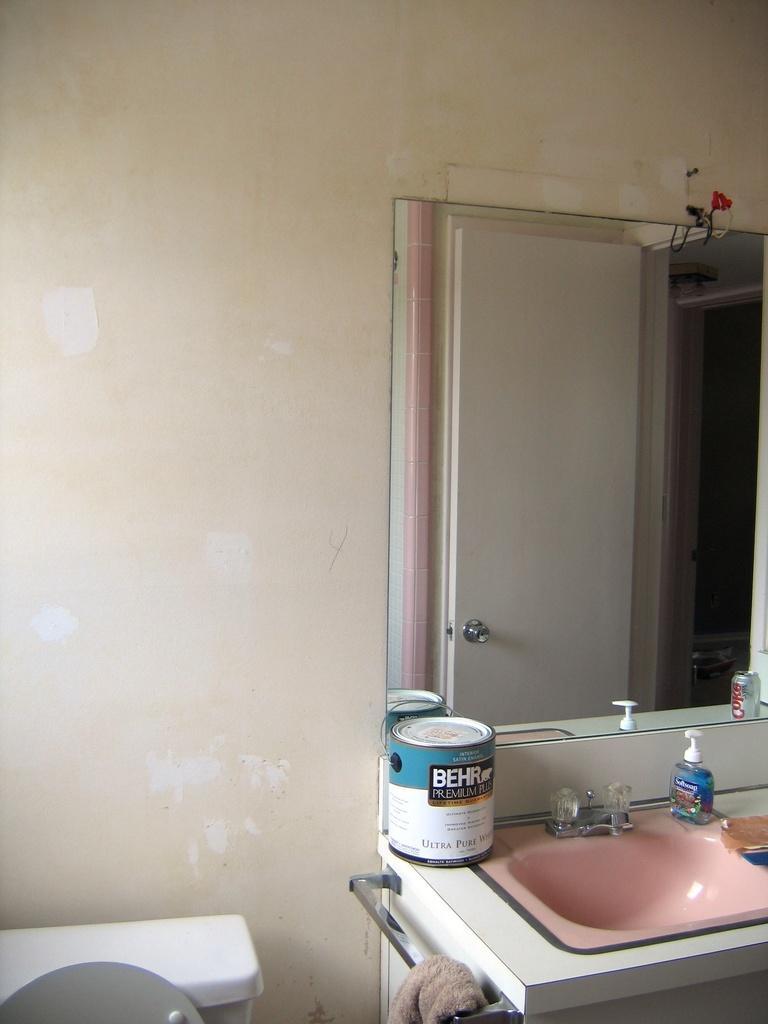Please provide a concise description of this image. As we can see in the image, there is a sink, tap, dettol hand wash, a box, mirror and white color wall. 